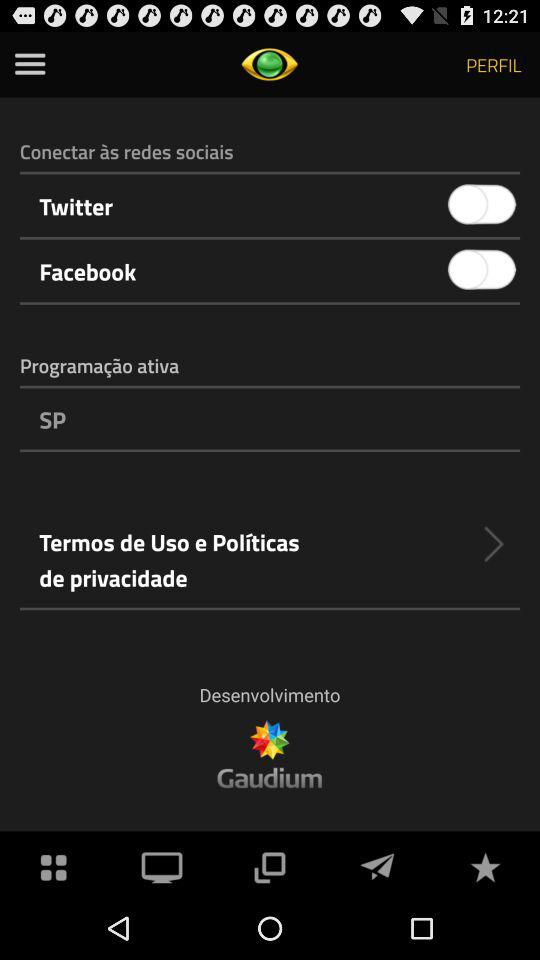How many social media platforms can be connected?
Answer the question using a single word or phrase. 2 